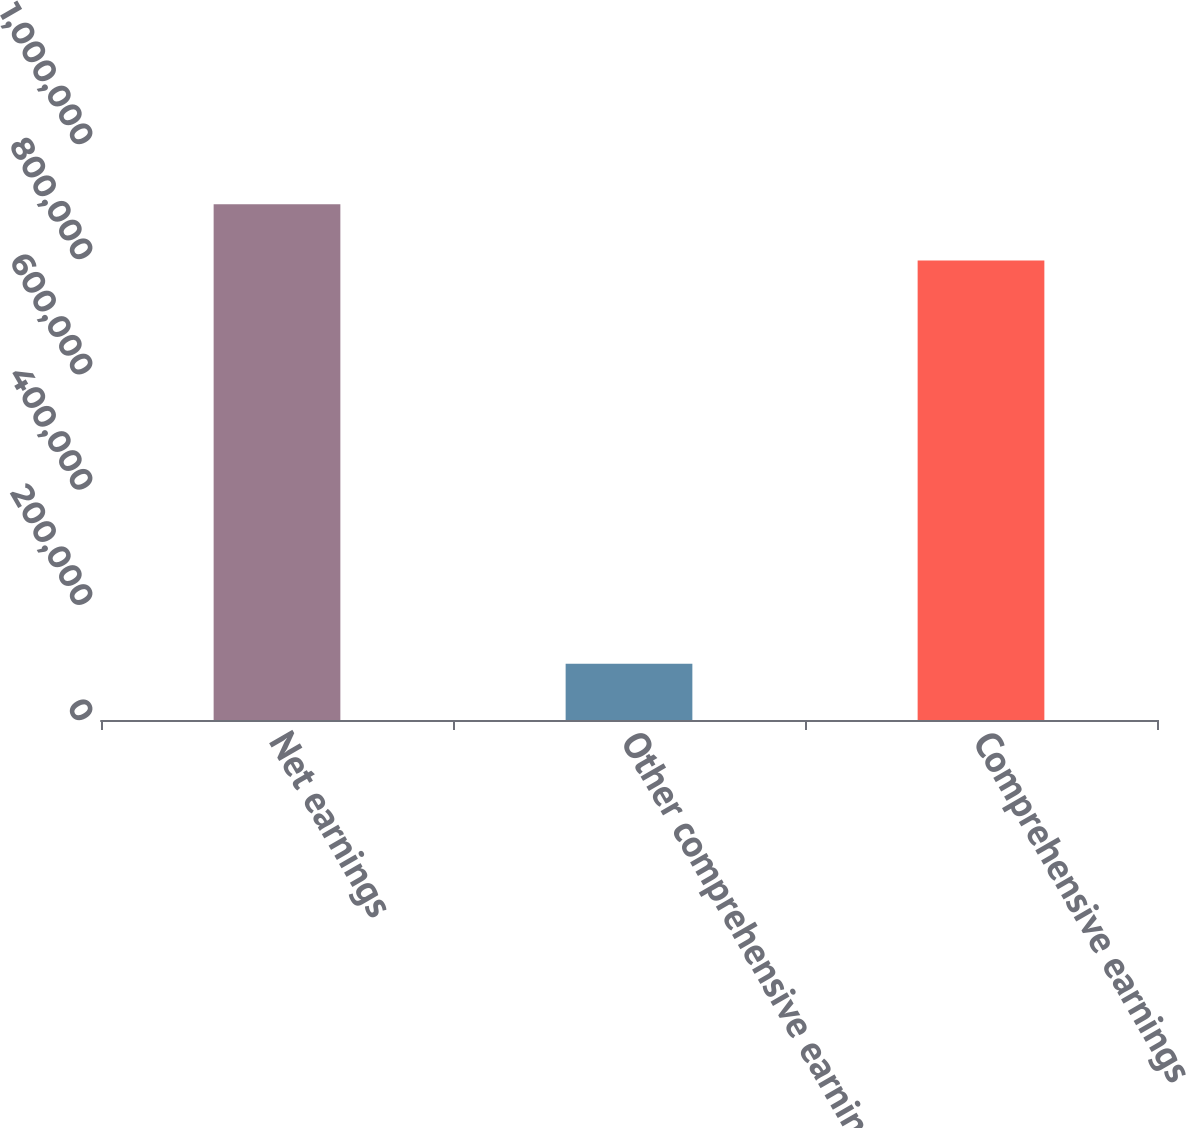<chart> <loc_0><loc_0><loc_500><loc_500><bar_chart><fcel>Net earnings<fcel>Other comprehensive earnings<fcel>Comprehensive earnings<nl><fcel>895243<fcel>97671<fcel>797572<nl></chart> 